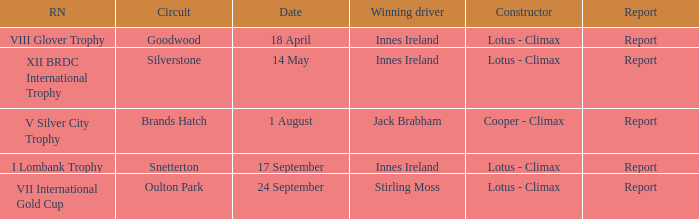What is the name of the race where Stirling Moss was the winning driver? VII International Gold Cup. Parse the table in full. {'header': ['RN', 'Circuit', 'Date', 'Winning driver', 'Constructor', 'Report'], 'rows': [['VIII Glover Trophy', 'Goodwood', '18 April', 'Innes Ireland', 'Lotus - Climax', 'Report'], ['XII BRDC International Trophy', 'Silverstone', '14 May', 'Innes Ireland', 'Lotus - Climax', 'Report'], ['V Silver City Trophy', 'Brands Hatch', '1 August', 'Jack Brabham', 'Cooper - Climax', 'Report'], ['I Lombank Trophy', 'Snetterton', '17 September', 'Innes Ireland', 'Lotus - Climax', 'Report'], ['VII International Gold Cup', 'Oulton Park', '24 September', 'Stirling Moss', 'Lotus - Climax', 'Report']]} 